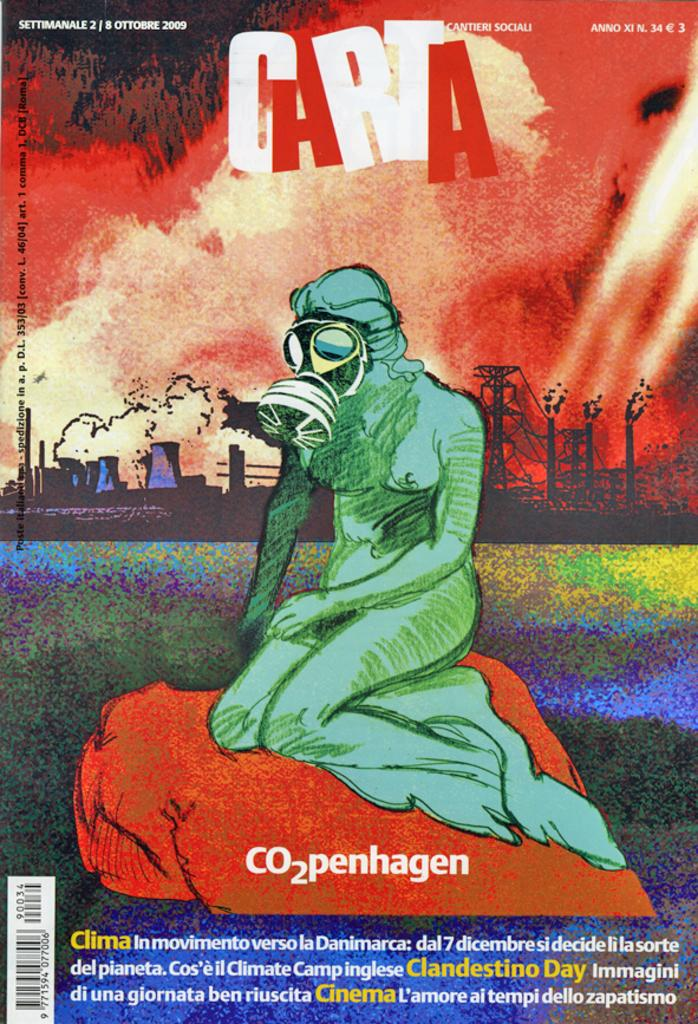<image>
Give a short and clear explanation of the subsequent image. a cartoon image of a gas masked person with carta above them 